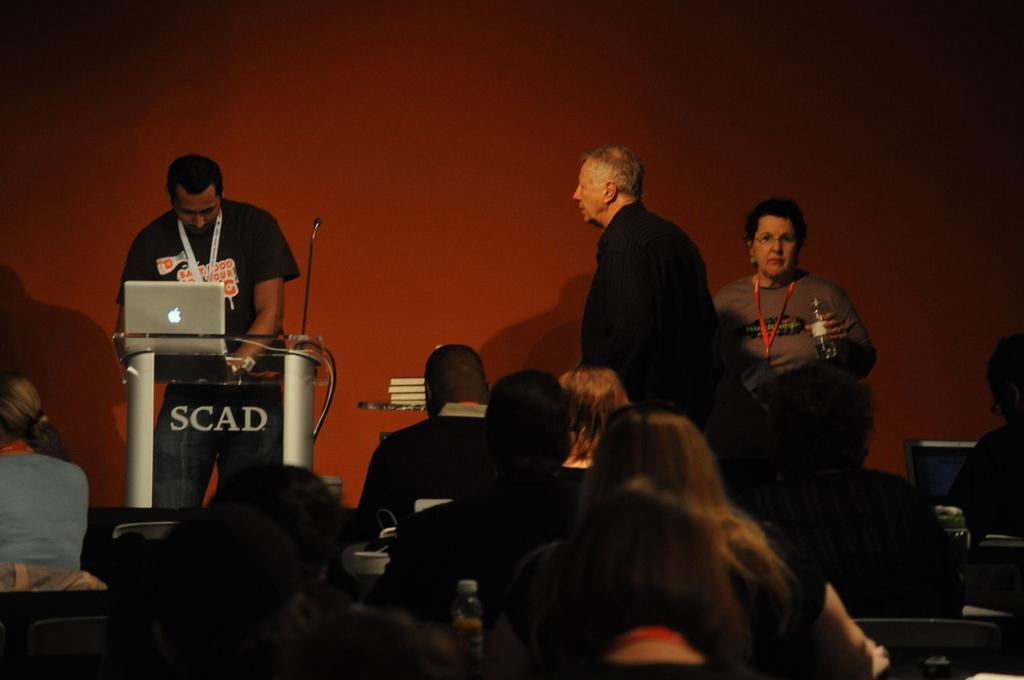Could you give a brief overview of what you see in this image? In this picture we can see a person standing on the path. There is a mic and a laptop on the podium. We can see a woman holding a bottle in her hand. There is a man standing. We can see a few people sitting on the chair from left yo right. There are some books on the shelf. A wall is visible in the background. 